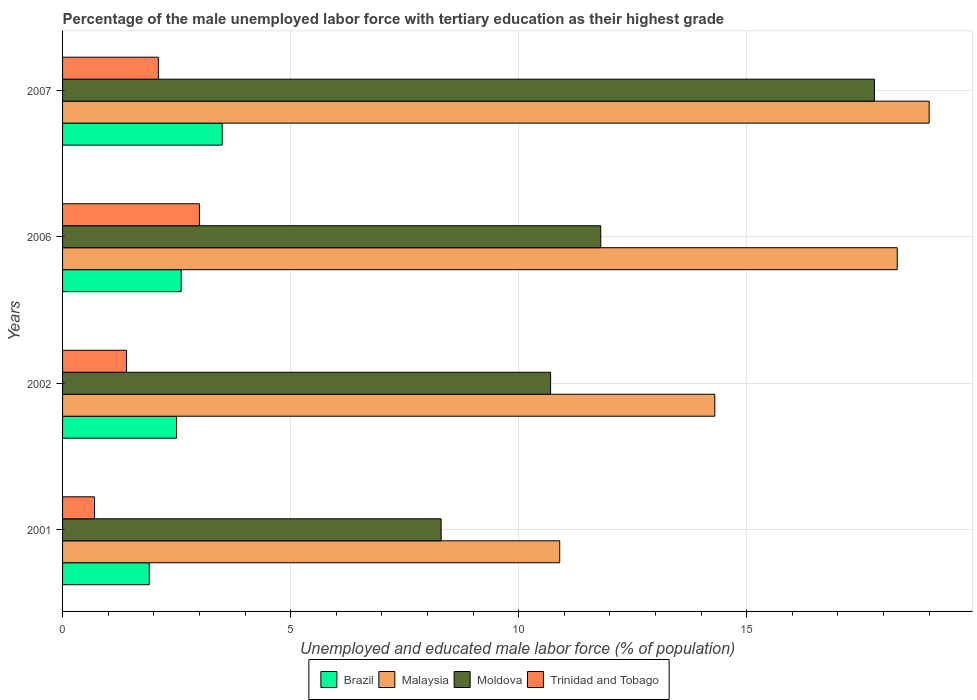Are the number of bars per tick equal to the number of legend labels?
Provide a succinct answer. Yes. How many bars are there on the 4th tick from the top?
Offer a very short reply. 4. In how many cases, is the number of bars for a given year not equal to the number of legend labels?
Keep it short and to the point. 0. What is the percentage of the unemployed male labor force with tertiary education in Brazil in 2001?
Give a very brief answer. 1.9. Across all years, what is the maximum percentage of the unemployed male labor force with tertiary education in Trinidad and Tobago?
Your answer should be compact. 3. Across all years, what is the minimum percentage of the unemployed male labor force with tertiary education in Moldova?
Offer a terse response. 8.3. In which year was the percentage of the unemployed male labor force with tertiary education in Brazil minimum?
Your answer should be compact. 2001. What is the total percentage of the unemployed male labor force with tertiary education in Brazil in the graph?
Ensure brevity in your answer.  10.5. What is the difference between the percentage of the unemployed male labor force with tertiary education in Moldova in 2001 and that in 2002?
Give a very brief answer. -2.4. What is the difference between the percentage of the unemployed male labor force with tertiary education in Trinidad and Tobago in 2006 and the percentage of the unemployed male labor force with tertiary education in Malaysia in 2001?
Your response must be concise. -7.9. What is the average percentage of the unemployed male labor force with tertiary education in Trinidad and Tobago per year?
Keep it short and to the point. 1.8. In the year 2006, what is the difference between the percentage of the unemployed male labor force with tertiary education in Moldova and percentage of the unemployed male labor force with tertiary education in Trinidad and Tobago?
Provide a short and direct response. 8.8. What is the ratio of the percentage of the unemployed male labor force with tertiary education in Trinidad and Tobago in 2002 to that in 2006?
Ensure brevity in your answer.  0.47. Is the difference between the percentage of the unemployed male labor force with tertiary education in Moldova in 2001 and 2002 greater than the difference between the percentage of the unemployed male labor force with tertiary education in Trinidad and Tobago in 2001 and 2002?
Ensure brevity in your answer.  No. What is the difference between the highest and the second highest percentage of the unemployed male labor force with tertiary education in Moldova?
Make the answer very short. 6. What is the difference between the highest and the lowest percentage of the unemployed male labor force with tertiary education in Moldova?
Keep it short and to the point. 9.5. Is the sum of the percentage of the unemployed male labor force with tertiary education in Trinidad and Tobago in 2001 and 2006 greater than the maximum percentage of the unemployed male labor force with tertiary education in Brazil across all years?
Your answer should be very brief. Yes. Is it the case that in every year, the sum of the percentage of the unemployed male labor force with tertiary education in Malaysia and percentage of the unemployed male labor force with tertiary education in Trinidad and Tobago is greater than the sum of percentage of the unemployed male labor force with tertiary education in Brazil and percentage of the unemployed male labor force with tertiary education in Moldova?
Provide a succinct answer. Yes. What does the 2nd bar from the top in 2007 represents?
Offer a very short reply. Moldova. What does the 2nd bar from the bottom in 2002 represents?
Provide a succinct answer. Malaysia. Is it the case that in every year, the sum of the percentage of the unemployed male labor force with tertiary education in Moldova and percentage of the unemployed male labor force with tertiary education in Brazil is greater than the percentage of the unemployed male labor force with tertiary education in Trinidad and Tobago?
Keep it short and to the point. Yes. How many bars are there?
Offer a very short reply. 16. Are the values on the major ticks of X-axis written in scientific E-notation?
Your answer should be compact. No. Where does the legend appear in the graph?
Give a very brief answer. Bottom center. How many legend labels are there?
Provide a succinct answer. 4. What is the title of the graph?
Your response must be concise. Percentage of the male unemployed labor force with tertiary education as their highest grade. Does "Luxembourg" appear as one of the legend labels in the graph?
Provide a succinct answer. No. What is the label or title of the X-axis?
Keep it short and to the point. Unemployed and educated male labor force (% of population). What is the label or title of the Y-axis?
Make the answer very short. Years. What is the Unemployed and educated male labor force (% of population) in Brazil in 2001?
Provide a succinct answer. 1.9. What is the Unemployed and educated male labor force (% of population) of Malaysia in 2001?
Offer a terse response. 10.9. What is the Unemployed and educated male labor force (% of population) of Moldova in 2001?
Your answer should be compact. 8.3. What is the Unemployed and educated male labor force (% of population) of Trinidad and Tobago in 2001?
Keep it short and to the point. 0.7. What is the Unemployed and educated male labor force (% of population) of Malaysia in 2002?
Give a very brief answer. 14.3. What is the Unemployed and educated male labor force (% of population) of Moldova in 2002?
Your answer should be very brief. 10.7. What is the Unemployed and educated male labor force (% of population) in Trinidad and Tobago in 2002?
Provide a succinct answer. 1.4. What is the Unemployed and educated male labor force (% of population) of Brazil in 2006?
Provide a succinct answer. 2.6. What is the Unemployed and educated male labor force (% of population) of Malaysia in 2006?
Your response must be concise. 18.3. What is the Unemployed and educated male labor force (% of population) in Moldova in 2006?
Your answer should be compact. 11.8. What is the Unemployed and educated male labor force (% of population) of Brazil in 2007?
Your response must be concise. 3.5. What is the Unemployed and educated male labor force (% of population) of Malaysia in 2007?
Ensure brevity in your answer.  19. What is the Unemployed and educated male labor force (% of population) in Moldova in 2007?
Your answer should be compact. 17.8. What is the Unemployed and educated male labor force (% of population) in Trinidad and Tobago in 2007?
Offer a terse response. 2.1. Across all years, what is the maximum Unemployed and educated male labor force (% of population) in Brazil?
Offer a very short reply. 3.5. Across all years, what is the maximum Unemployed and educated male labor force (% of population) of Moldova?
Your answer should be very brief. 17.8. Across all years, what is the minimum Unemployed and educated male labor force (% of population) of Brazil?
Your response must be concise. 1.9. Across all years, what is the minimum Unemployed and educated male labor force (% of population) of Malaysia?
Make the answer very short. 10.9. Across all years, what is the minimum Unemployed and educated male labor force (% of population) of Moldova?
Offer a very short reply. 8.3. Across all years, what is the minimum Unemployed and educated male labor force (% of population) of Trinidad and Tobago?
Ensure brevity in your answer.  0.7. What is the total Unemployed and educated male labor force (% of population) in Malaysia in the graph?
Keep it short and to the point. 62.5. What is the total Unemployed and educated male labor force (% of population) in Moldova in the graph?
Offer a very short reply. 48.6. What is the total Unemployed and educated male labor force (% of population) in Trinidad and Tobago in the graph?
Offer a very short reply. 7.2. What is the difference between the Unemployed and educated male labor force (% of population) in Malaysia in 2001 and that in 2002?
Ensure brevity in your answer.  -3.4. What is the difference between the Unemployed and educated male labor force (% of population) in Brazil in 2001 and that in 2007?
Keep it short and to the point. -1.6. What is the difference between the Unemployed and educated male labor force (% of population) in Malaysia in 2001 and that in 2007?
Offer a terse response. -8.1. What is the difference between the Unemployed and educated male labor force (% of population) of Moldova in 2001 and that in 2007?
Your response must be concise. -9.5. What is the difference between the Unemployed and educated male labor force (% of population) in Moldova in 2002 and that in 2006?
Provide a succinct answer. -1.1. What is the difference between the Unemployed and educated male labor force (% of population) of Trinidad and Tobago in 2002 and that in 2006?
Offer a terse response. -1.6. What is the difference between the Unemployed and educated male labor force (% of population) of Brazil in 2002 and that in 2007?
Your answer should be very brief. -1. What is the difference between the Unemployed and educated male labor force (% of population) in Malaysia in 2002 and that in 2007?
Give a very brief answer. -4.7. What is the difference between the Unemployed and educated male labor force (% of population) of Moldova in 2002 and that in 2007?
Give a very brief answer. -7.1. What is the difference between the Unemployed and educated male labor force (% of population) in Trinidad and Tobago in 2002 and that in 2007?
Give a very brief answer. -0.7. What is the difference between the Unemployed and educated male labor force (% of population) in Brazil in 2006 and that in 2007?
Offer a very short reply. -0.9. What is the difference between the Unemployed and educated male labor force (% of population) in Moldova in 2006 and that in 2007?
Your response must be concise. -6. What is the difference between the Unemployed and educated male labor force (% of population) in Trinidad and Tobago in 2006 and that in 2007?
Ensure brevity in your answer.  0.9. What is the difference between the Unemployed and educated male labor force (% of population) of Brazil in 2001 and the Unemployed and educated male labor force (% of population) of Malaysia in 2002?
Offer a terse response. -12.4. What is the difference between the Unemployed and educated male labor force (% of population) of Brazil in 2001 and the Unemployed and educated male labor force (% of population) of Moldova in 2002?
Your answer should be very brief. -8.8. What is the difference between the Unemployed and educated male labor force (% of population) of Malaysia in 2001 and the Unemployed and educated male labor force (% of population) of Trinidad and Tobago in 2002?
Keep it short and to the point. 9.5. What is the difference between the Unemployed and educated male labor force (% of population) of Brazil in 2001 and the Unemployed and educated male labor force (% of population) of Malaysia in 2006?
Give a very brief answer. -16.4. What is the difference between the Unemployed and educated male labor force (% of population) in Brazil in 2001 and the Unemployed and educated male labor force (% of population) in Moldova in 2006?
Provide a short and direct response. -9.9. What is the difference between the Unemployed and educated male labor force (% of population) of Brazil in 2001 and the Unemployed and educated male labor force (% of population) of Trinidad and Tobago in 2006?
Keep it short and to the point. -1.1. What is the difference between the Unemployed and educated male labor force (% of population) of Malaysia in 2001 and the Unemployed and educated male labor force (% of population) of Trinidad and Tobago in 2006?
Your answer should be very brief. 7.9. What is the difference between the Unemployed and educated male labor force (% of population) in Brazil in 2001 and the Unemployed and educated male labor force (% of population) in Malaysia in 2007?
Offer a very short reply. -17.1. What is the difference between the Unemployed and educated male labor force (% of population) in Brazil in 2001 and the Unemployed and educated male labor force (% of population) in Moldova in 2007?
Your answer should be very brief. -15.9. What is the difference between the Unemployed and educated male labor force (% of population) of Malaysia in 2001 and the Unemployed and educated male labor force (% of population) of Moldova in 2007?
Provide a short and direct response. -6.9. What is the difference between the Unemployed and educated male labor force (% of population) in Moldova in 2001 and the Unemployed and educated male labor force (% of population) in Trinidad and Tobago in 2007?
Give a very brief answer. 6.2. What is the difference between the Unemployed and educated male labor force (% of population) of Brazil in 2002 and the Unemployed and educated male labor force (% of population) of Malaysia in 2006?
Provide a short and direct response. -15.8. What is the difference between the Unemployed and educated male labor force (% of population) of Brazil in 2002 and the Unemployed and educated male labor force (% of population) of Trinidad and Tobago in 2006?
Your response must be concise. -0.5. What is the difference between the Unemployed and educated male labor force (% of population) of Malaysia in 2002 and the Unemployed and educated male labor force (% of population) of Moldova in 2006?
Your response must be concise. 2.5. What is the difference between the Unemployed and educated male labor force (% of population) of Moldova in 2002 and the Unemployed and educated male labor force (% of population) of Trinidad and Tobago in 2006?
Ensure brevity in your answer.  7.7. What is the difference between the Unemployed and educated male labor force (% of population) of Brazil in 2002 and the Unemployed and educated male labor force (% of population) of Malaysia in 2007?
Ensure brevity in your answer.  -16.5. What is the difference between the Unemployed and educated male labor force (% of population) in Brazil in 2002 and the Unemployed and educated male labor force (% of population) in Moldova in 2007?
Give a very brief answer. -15.3. What is the difference between the Unemployed and educated male labor force (% of population) of Brazil in 2002 and the Unemployed and educated male labor force (% of population) of Trinidad and Tobago in 2007?
Ensure brevity in your answer.  0.4. What is the difference between the Unemployed and educated male labor force (% of population) in Brazil in 2006 and the Unemployed and educated male labor force (% of population) in Malaysia in 2007?
Give a very brief answer. -16.4. What is the difference between the Unemployed and educated male labor force (% of population) of Brazil in 2006 and the Unemployed and educated male labor force (% of population) of Moldova in 2007?
Your answer should be very brief. -15.2. What is the difference between the Unemployed and educated male labor force (% of population) in Malaysia in 2006 and the Unemployed and educated male labor force (% of population) in Trinidad and Tobago in 2007?
Offer a terse response. 16.2. What is the difference between the Unemployed and educated male labor force (% of population) of Moldova in 2006 and the Unemployed and educated male labor force (% of population) of Trinidad and Tobago in 2007?
Offer a terse response. 9.7. What is the average Unemployed and educated male labor force (% of population) of Brazil per year?
Keep it short and to the point. 2.62. What is the average Unemployed and educated male labor force (% of population) in Malaysia per year?
Offer a very short reply. 15.62. What is the average Unemployed and educated male labor force (% of population) of Moldova per year?
Offer a very short reply. 12.15. In the year 2001, what is the difference between the Unemployed and educated male labor force (% of population) of Brazil and Unemployed and educated male labor force (% of population) of Moldova?
Provide a short and direct response. -6.4. In the year 2002, what is the difference between the Unemployed and educated male labor force (% of population) in Brazil and Unemployed and educated male labor force (% of population) in Trinidad and Tobago?
Make the answer very short. 1.1. In the year 2002, what is the difference between the Unemployed and educated male labor force (% of population) in Moldova and Unemployed and educated male labor force (% of population) in Trinidad and Tobago?
Your response must be concise. 9.3. In the year 2006, what is the difference between the Unemployed and educated male labor force (% of population) of Brazil and Unemployed and educated male labor force (% of population) of Malaysia?
Your answer should be very brief. -15.7. In the year 2006, what is the difference between the Unemployed and educated male labor force (% of population) of Brazil and Unemployed and educated male labor force (% of population) of Moldova?
Your answer should be very brief. -9.2. In the year 2006, what is the difference between the Unemployed and educated male labor force (% of population) in Brazil and Unemployed and educated male labor force (% of population) in Trinidad and Tobago?
Your response must be concise. -0.4. In the year 2006, what is the difference between the Unemployed and educated male labor force (% of population) of Malaysia and Unemployed and educated male labor force (% of population) of Moldova?
Your response must be concise. 6.5. In the year 2006, what is the difference between the Unemployed and educated male labor force (% of population) of Moldova and Unemployed and educated male labor force (% of population) of Trinidad and Tobago?
Your answer should be very brief. 8.8. In the year 2007, what is the difference between the Unemployed and educated male labor force (% of population) in Brazil and Unemployed and educated male labor force (% of population) in Malaysia?
Provide a succinct answer. -15.5. In the year 2007, what is the difference between the Unemployed and educated male labor force (% of population) in Brazil and Unemployed and educated male labor force (% of population) in Moldova?
Your answer should be very brief. -14.3. In the year 2007, what is the difference between the Unemployed and educated male labor force (% of population) in Malaysia and Unemployed and educated male labor force (% of population) in Trinidad and Tobago?
Your response must be concise. 16.9. What is the ratio of the Unemployed and educated male labor force (% of population) of Brazil in 2001 to that in 2002?
Make the answer very short. 0.76. What is the ratio of the Unemployed and educated male labor force (% of population) of Malaysia in 2001 to that in 2002?
Make the answer very short. 0.76. What is the ratio of the Unemployed and educated male labor force (% of population) in Moldova in 2001 to that in 2002?
Provide a short and direct response. 0.78. What is the ratio of the Unemployed and educated male labor force (% of population) of Trinidad and Tobago in 2001 to that in 2002?
Give a very brief answer. 0.5. What is the ratio of the Unemployed and educated male labor force (% of population) in Brazil in 2001 to that in 2006?
Give a very brief answer. 0.73. What is the ratio of the Unemployed and educated male labor force (% of population) in Malaysia in 2001 to that in 2006?
Provide a short and direct response. 0.6. What is the ratio of the Unemployed and educated male labor force (% of population) in Moldova in 2001 to that in 2006?
Your response must be concise. 0.7. What is the ratio of the Unemployed and educated male labor force (% of population) of Trinidad and Tobago in 2001 to that in 2006?
Offer a terse response. 0.23. What is the ratio of the Unemployed and educated male labor force (% of population) in Brazil in 2001 to that in 2007?
Ensure brevity in your answer.  0.54. What is the ratio of the Unemployed and educated male labor force (% of population) in Malaysia in 2001 to that in 2007?
Offer a very short reply. 0.57. What is the ratio of the Unemployed and educated male labor force (% of population) of Moldova in 2001 to that in 2007?
Give a very brief answer. 0.47. What is the ratio of the Unemployed and educated male labor force (% of population) in Brazil in 2002 to that in 2006?
Offer a terse response. 0.96. What is the ratio of the Unemployed and educated male labor force (% of population) of Malaysia in 2002 to that in 2006?
Offer a very short reply. 0.78. What is the ratio of the Unemployed and educated male labor force (% of population) in Moldova in 2002 to that in 2006?
Your answer should be compact. 0.91. What is the ratio of the Unemployed and educated male labor force (% of population) in Trinidad and Tobago in 2002 to that in 2006?
Keep it short and to the point. 0.47. What is the ratio of the Unemployed and educated male labor force (% of population) of Malaysia in 2002 to that in 2007?
Provide a succinct answer. 0.75. What is the ratio of the Unemployed and educated male labor force (% of population) of Moldova in 2002 to that in 2007?
Offer a very short reply. 0.6. What is the ratio of the Unemployed and educated male labor force (% of population) in Brazil in 2006 to that in 2007?
Provide a succinct answer. 0.74. What is the ratio of the Unemployed and educated male labor force (% of population) of Malaysia in 2006 to that in 2007?
Keep it short and to the point. 0.96. What is the ratio of the Unemployed and educated male labor force (% of population) in Moldova in 2006 to that in 2007?
Offer a very short reply. 0.66. What is the ratio of the Unemployed and educated male labor force (% of population) of Trinidad and Tobago in 2006 to that in 2007?
Your answer should be compact. 1.43. What is the difference between the highest and the second highest Unemployed and educated male labor force (% of population) in Moldova?
Ensure brevity in your answer.  6. What is the difference between the highest and the second highest Unemployed and educated male labor force (% of population) of Trinidad and Tobago?
Make the answer very short. 0.9. What is the difference between the highest and the lowest Unemployed and educated male labor force (% of population) of Brazil?
Your answer should be compact. 1.6. What is the difference between the highest and the lowest Unemployed and educated male labor force (% of population) in Malaysia?
Give a very brief answer. 8.1. 